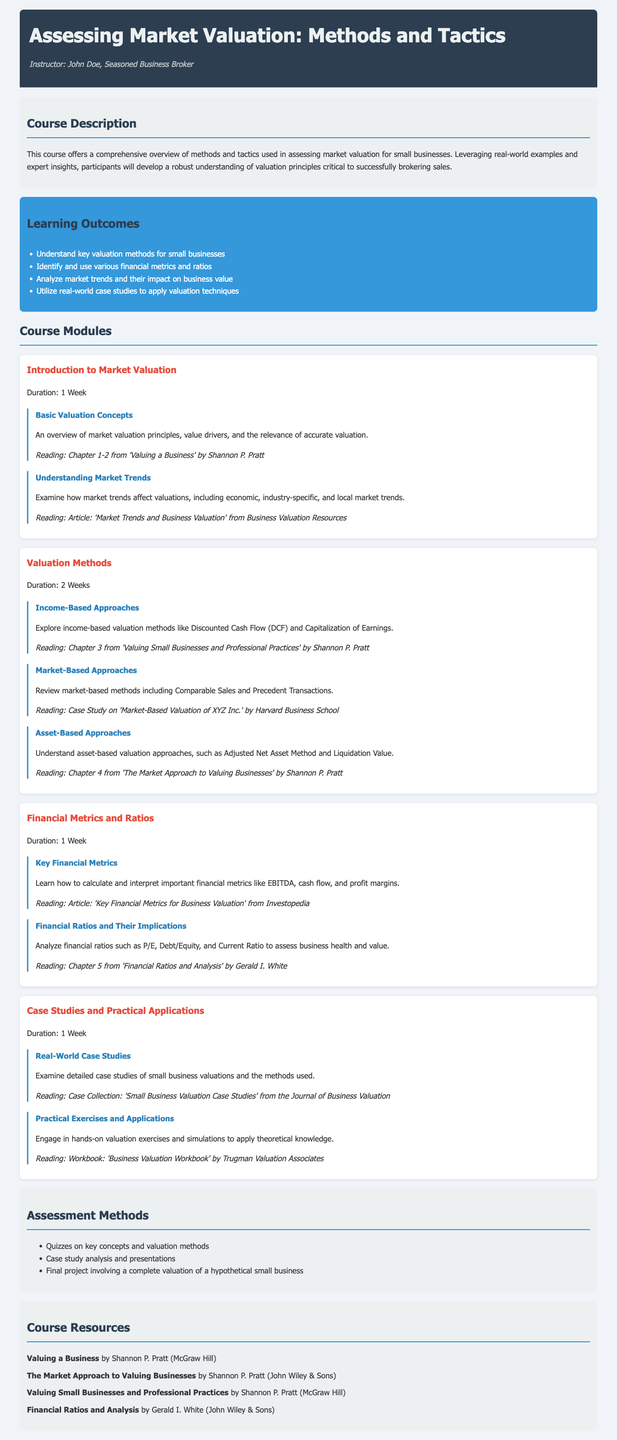What is the course title? The course title is found in the header section of the document.
Answer: Assessing Market Valuation: Methods and Tactics Who is the instructor? The instructor's name is mentioned directly under the course title.
Answer: John Doe What is the duration of the "Valuation Methods" module? The duration is stated in the module's section of the document.
Answer: 2 Weeks Name one financial metric that is covered in the course. The course mentions specific financial metrics in the relevant module section.
Answer: EBITDA What type of assessment is included in the course? The types of assessments are listed in the assessment methods section.
Answer: Quizzes on key concepts and valuation methods What is one of the learning outcomes? The learning outcomes are detailed in a list in the syllabus.
Answer: Understand key valuation methods for small businesses What reading is assigned for "Understanding Market Trends"? The specific reading assignment is provided in the module section.
Answer: Article: 'Market Trends and Business Valuation' from Business Valuation Resources Which book by Shannon P. Pratt is mentioned as a resource? The resources section lists relevant books which include titles by this author.
Answer: Valuing a Business What is the focus of the "Case Studies and Practical Applications" module? The focus is outlined in the module's description and specific topics.
Answer: Real-World Case Studies 